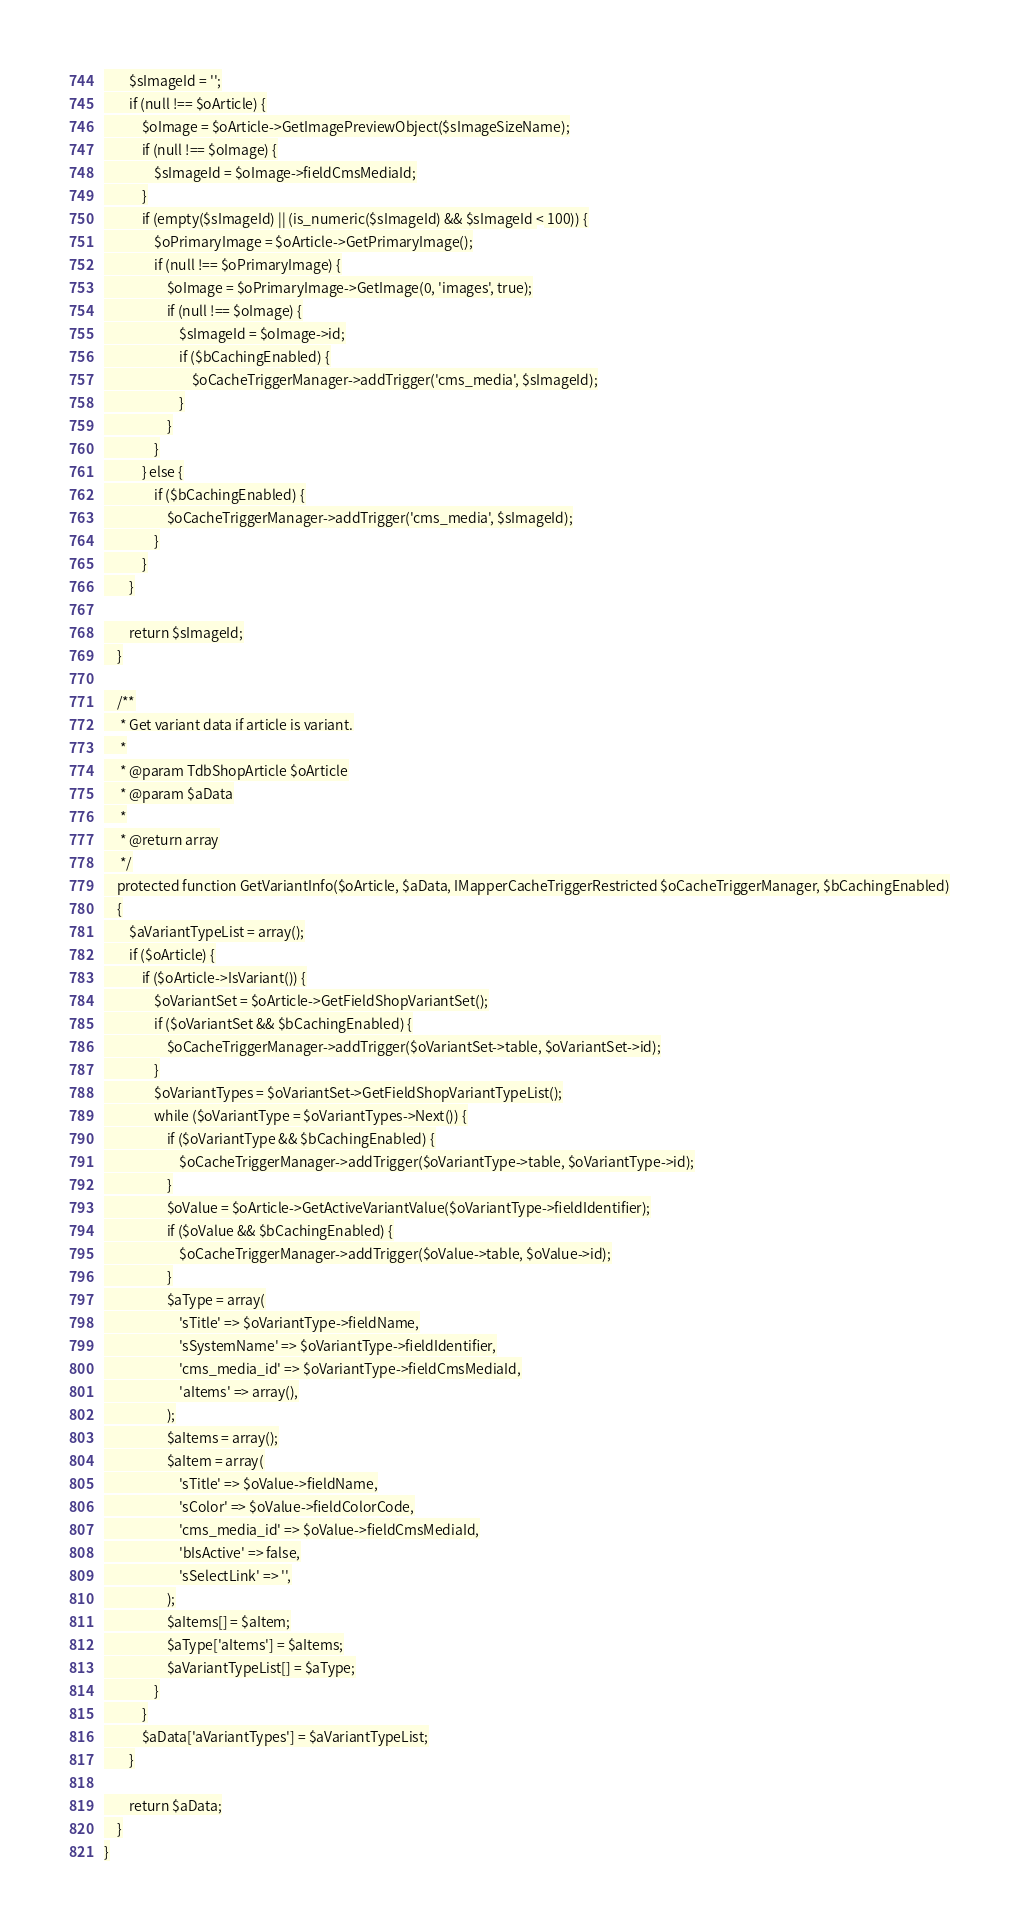Convert code to text. <code><loc_0><loc_0><loc_500><loc_500><_PHP_>        $sImageId = '';
        if (null !== $oArticle) {
            $oImage = $oArticle->GetImagePreviewObject($sImageSizeName);
            if (null !== $oImage) {
                $sImageId = $oImage->fieldCmsMediaId;
            }
            if (empty($sImageId) || (is_numeric($sImageId) && $sImageId < 100)) {
                $oPrimaryImage = $oArticle->GetPrimaryImage();
                if (null !== $oPrimaryImage) {
                    $oImage = $oPrimaryImage->GetImage(0, 'images', true);
                    if (null !== $oImage) {
                        $sImageId = $oImage->id;
                        if ($bCachingEnabled) {
                            $oCacheTriggerManager->addTrigger('cms_media', $sImageId);
                        }
                    }
                }
            } else {
                if ($bCachingEnabled) {
                    $oCacheTriggerManager->addTrigger('cms_media', $sImageId);
                }
            }
        }

        return $sImageId;
    }

    /**
     * Get variant data if article is variant.
     *
     * @param TdbShopArticle $oArticle
     * @param $aData
     *
     * @return array
     */
    protected function GetVariantInfo($oArticle, $aData, IMapperCacheTriggerRestricted $oCacheTriggerManager, $bCachingEnabled)
    {
        $aVariantTypeList = array();
        if ($oArticle) {
            if ($oArticle->IsVariant()) {
                $oVariantSet = $oArticle->GetFieldShopVariantSet();
                if ($oVariantSet && $bCachingEnabled) {
                    $oCacheTriggerManager->addTrigger($oVariantSet->table, $oVariantSet->id);
                }
                $oVariantTypes = $oVariantSet->GetFieldShopVariantTypeList();
                while ($oVariantType = $oVariantTypes->Next()) {
                    if ($oVariantType && $bCachingEnabled) {
                        $oCacheTriggerManager->addTrigger($oVariantType->table, $oVariantType->id);
                    }
                    $oValue = $oArticle->GetActiveVariantValue($oVariantType->fieldIdentifier);
                    if ($oValue && $bCachingEnabled) {
                        $oCacheTriggerManager->addTrigger($oValue->table, $oValue->id);
                    }
                    $aType = array(
                        'sTitle' => $oVariantType->fieldName,
                        'sSystemName' => $oVariantType->fieldIdentifier,
                        'cms_media_id' => $oVariantType->fieldCmsMediaId,
                        'aItems' => array(),
                    );
                    $aItems = array();
                    $aItem = array(
                        'sTitle' => $oValue->fieldName,
                        'sColor' => $oValue->fieldColorCode,
                        'cms_media_id' => $oValue->fieldCmsMediaId,
                        'bIsActive' => false,
                        'sSelectLink' => '',
                    );
                    $aItems[] = $aItem;
                    $aType['aItems'] = $aItems;
                    $aVariantTypeList[] = $aType;
                }
            }
            $aData['aVariantTypes'] = $aVariantTypeList;
        }

        return $aData;
    }
}
</code> 